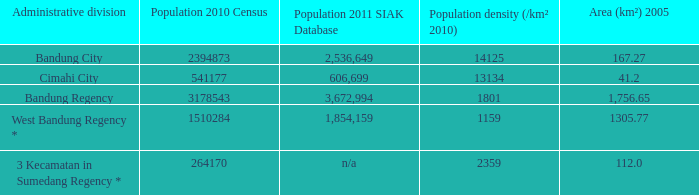Which administrative division had a population of 2011 according to the siak database of 3,672,994? Bandung Regency. Can you give me this table as a dict? {'header': ['Administrative division', 'Population 2010 Census', 'Population 2011 SIAK Database', 'Population density (/km² 2010)', 'Area (km²) 2005'], 'rows': [['Bandung City', '2394873', '2,536,649', '14125', '167.27'], ['Cimahi City', '541177', '606,699', '13134', '41.2'], ['Bandung Regency', '3178543', '3,672,994', '1801', '1,756.65'], ['West Bandung Regency *', '1510284', '1,854,159', '1159', '1305.77'], ['3 Kecamatan in Sumedang Regency *', '264170', 'n/a', '2359', '112.0']]} 